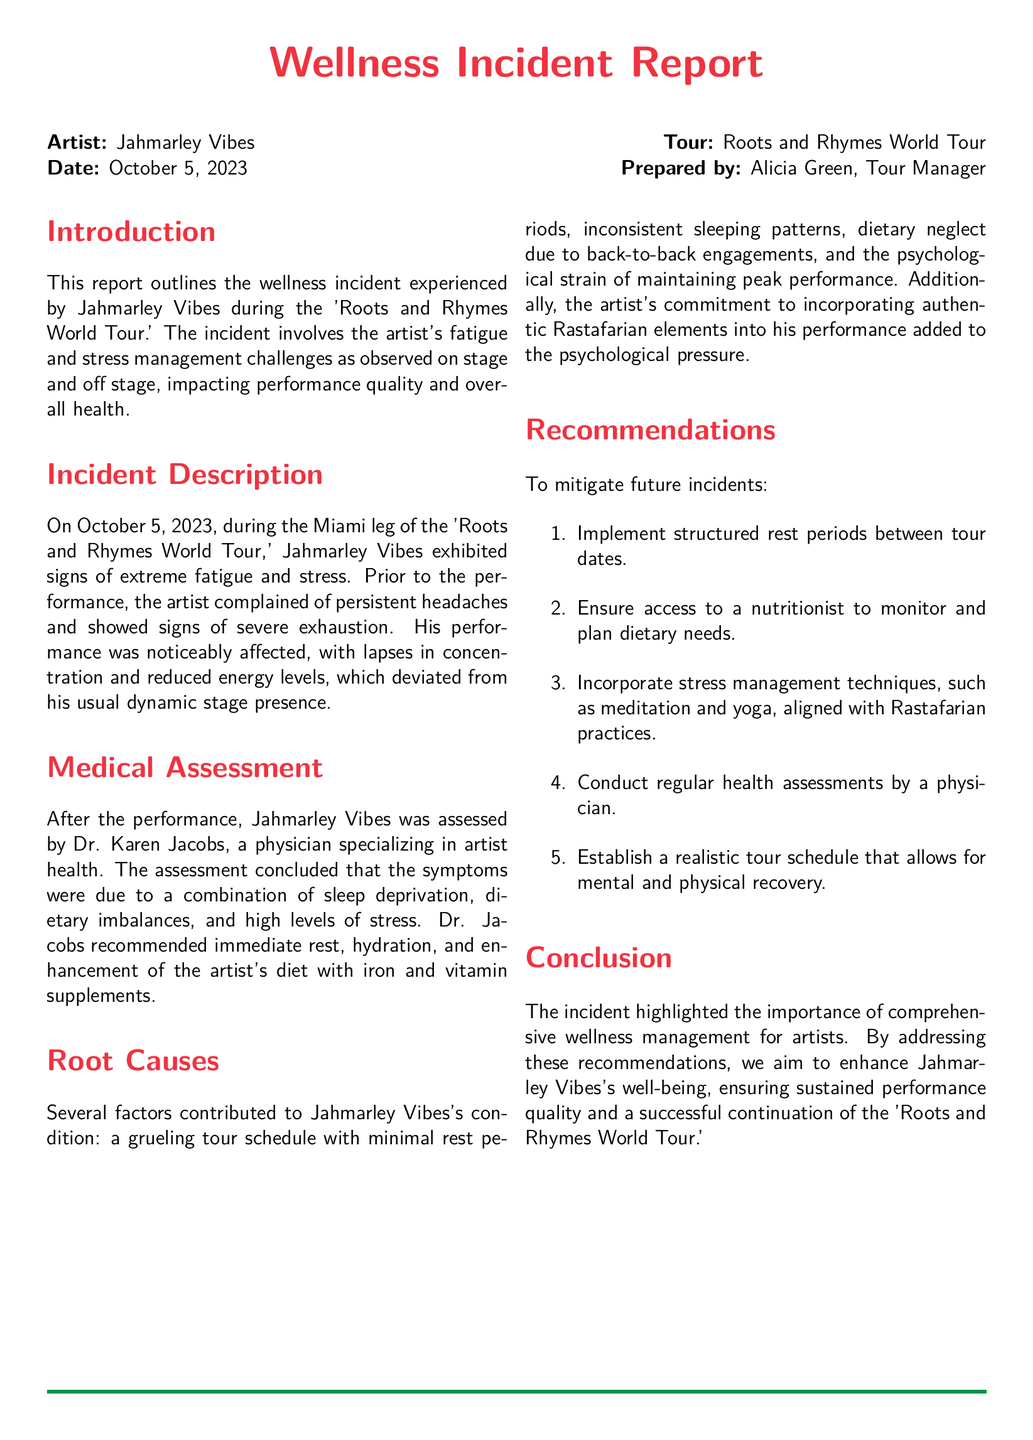What is the name of the artist? The artist's name is mentioned at the beginning of the report as Jahmarley Vibes.
Answer: Jahmarley Vibes What is the date of the incident? The date of the incident is clearly stated in the report as October 5, 2023.
Answer: October 5, 2023 Who prepared the report? The name of the person who prepared the report is given as Alicia Green, the Tour Manager.
Answer: Alicia Green What were the symptoms observed in the artist? The symptoms of the artist's condition included persistent headaches and signs of severe exhaustion.
Answer: Persistent headaches and severe exhaustion What was the main recommendation for the artist's health? One of the main recommendations was to implement structured rest periods between tour dates.
Answer: Structured rest periods What specialist assessed the artist after the performance? The physician who assessed Jahmarley Vibes is referred to as Dr. Karen Jacobs.
Answer: Dr. Karen Jacobs What contributed to the artist's fatigue? Contributing factors include sleep deprivation, dietary imbalances, and high levels of stress.
Answer: Sleep deprivation, dietary imbalances, and high stress What aspect of the performance added psychological pressure to the artist? The artist's commitment to incorporating authentic Rastafarian elements into his performance added to the psychological pressure.
Answer: Authentic Rastafarian elements What is the title of the tour? The tour's title, as stated at the beginning of the report, is Roots and Rhymes World Tour.
Answer: Roots and Rhymes World Tour 